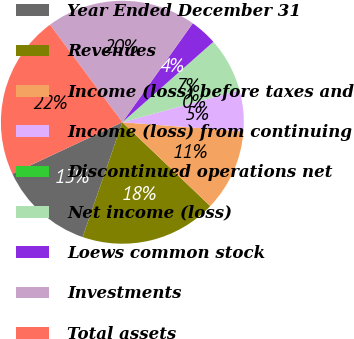Convert chart. <chart><loc_0><loc_0><loc_500><loc_500><pie_chart><fcel>Year Ended December 31<fcel>Revenues<fcel>Income (loss) before taxes and<fcel>Income (loss) from continuing<fcel>Discontinued operations net<fcel>Net income (loss)<fcel>Loews common stock<fcel>Investments<fcel>Total assets<nl><fcel>12.73%<fcel>18.18%<fcel>10.91%<fcel>5.46%<fcel>0.0%<fcel>7.27%<fcel>3.64%<fcel>20.0%<fcel>21.81%<nl></chart> 